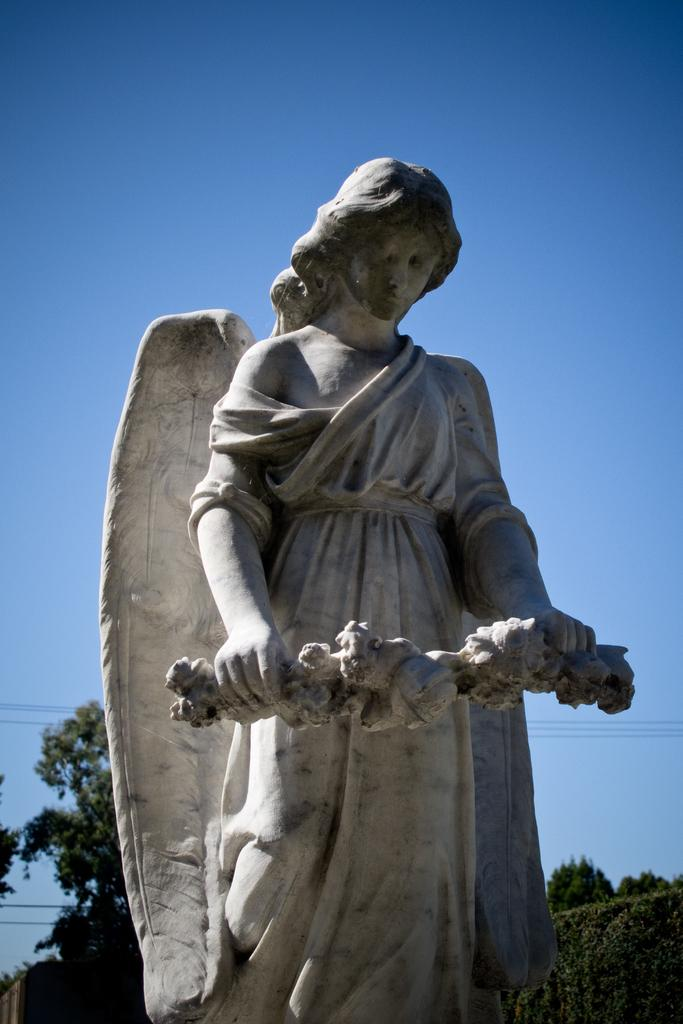What is the main subject of the image? The main subject of the image is a statue of a woman with wings. What is the statue holding in her hands? The statue is holding an object in her hands. What can be seen in the background of the image? There are trees visible behind the statue. What is visible at the top of the image? The sky is visible at the top of the image. What type of invention can be seen in the hands of the statue? There is no invention visible in the hands of the statue; it is holding an object, but the nature of the object is not specified. 